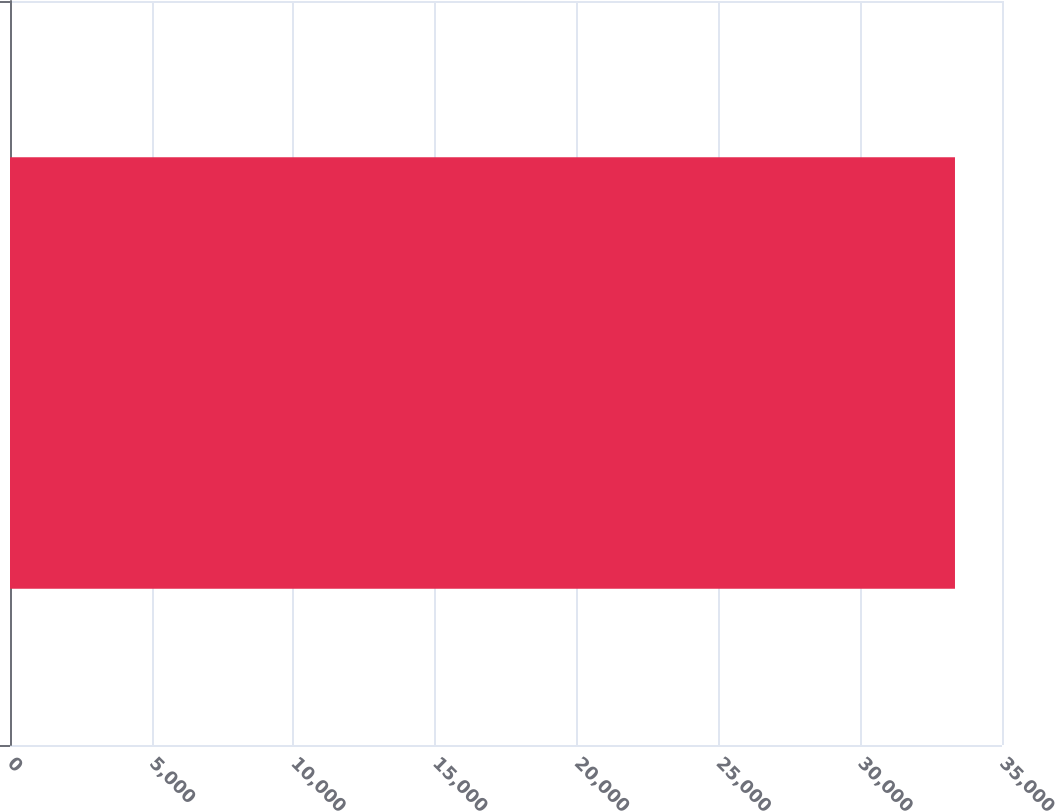Convert chart. <chart><loc_0><loc_0><loc_500><loc_500><bar_chart><ecel><nl><fcel>33341.2<nl></chart> 